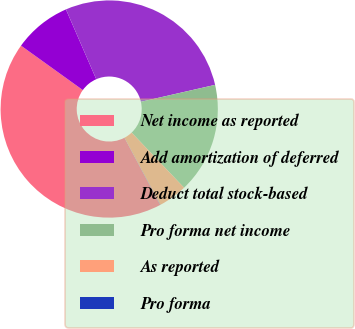Convert chart to OTSL. <chart><loc_0><loc_0><loc_500><loc_500><pie_chart><fcel>Net income as reported<fcel>Add amortization of deferred<fcel>Deduct total stock-based<fcel>Pro forma net income<fcel>As reported<fcel>Pro forma<nl><fcel>42.69%<fcel>8.56%<fcel>27.95%<fcel>16.47%<fcel>4.3%<fcel>0.03%<nl></chart> 